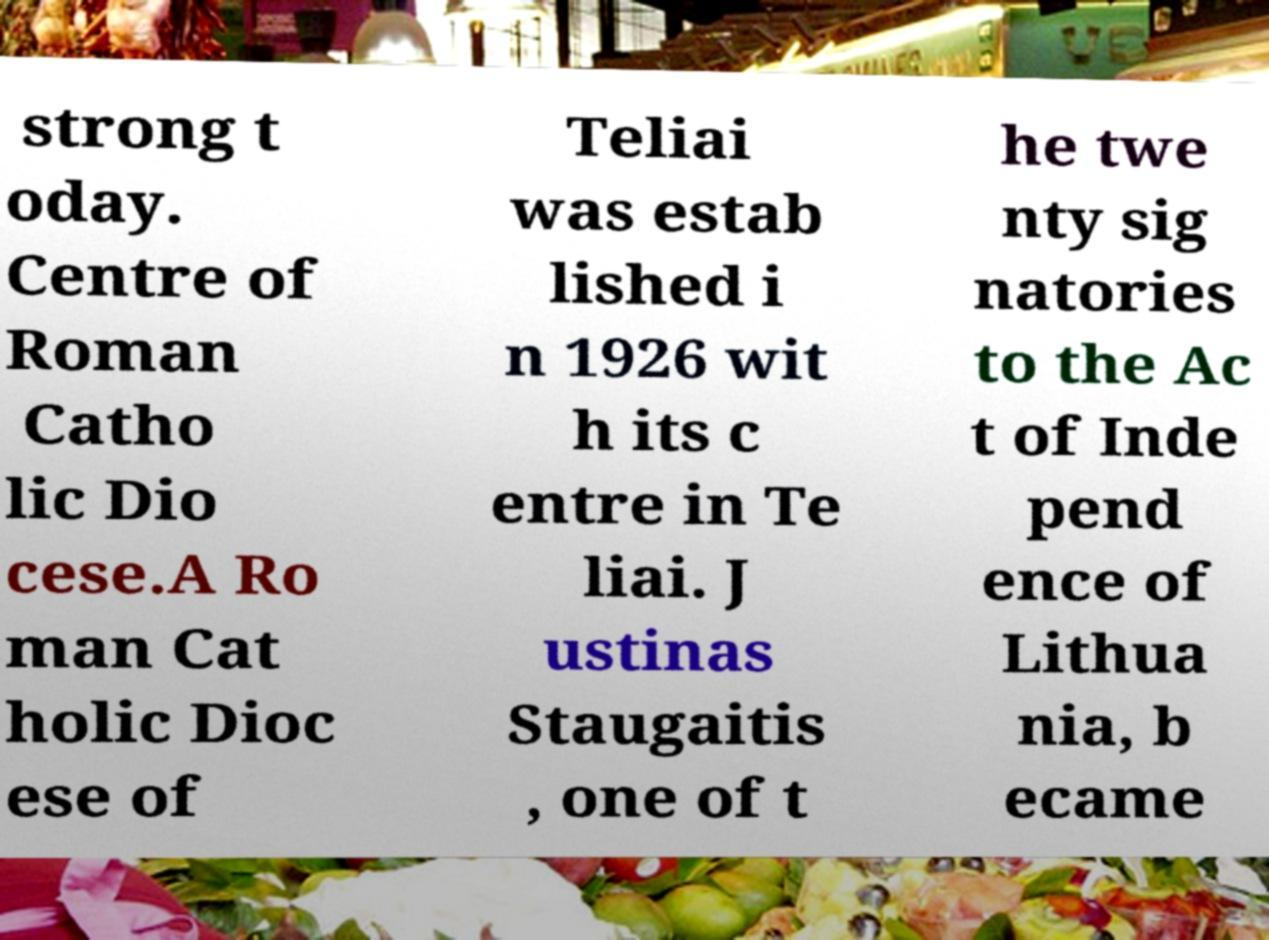Can you accurately transcribe the text from the provided image for me? strong t oday. Centre of Roman Catho lic Dio cese.A Ro man Cat holic Dioc ese of Teliai was estab lished i n 1926 wit h its c entre in Te liai. J ustinas Staugaitis , one of t he twe nty sig natories to the Ac t of Inde pend ence of Lithua nia, b ecame 